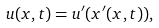Convert formula to latex. <formula><loc_0><loc_0><loc_500><loc_500>u ( x , t ) = u ^ { \prime } ( x ^ { \prime } ( x , t ) ) ,</formula> 